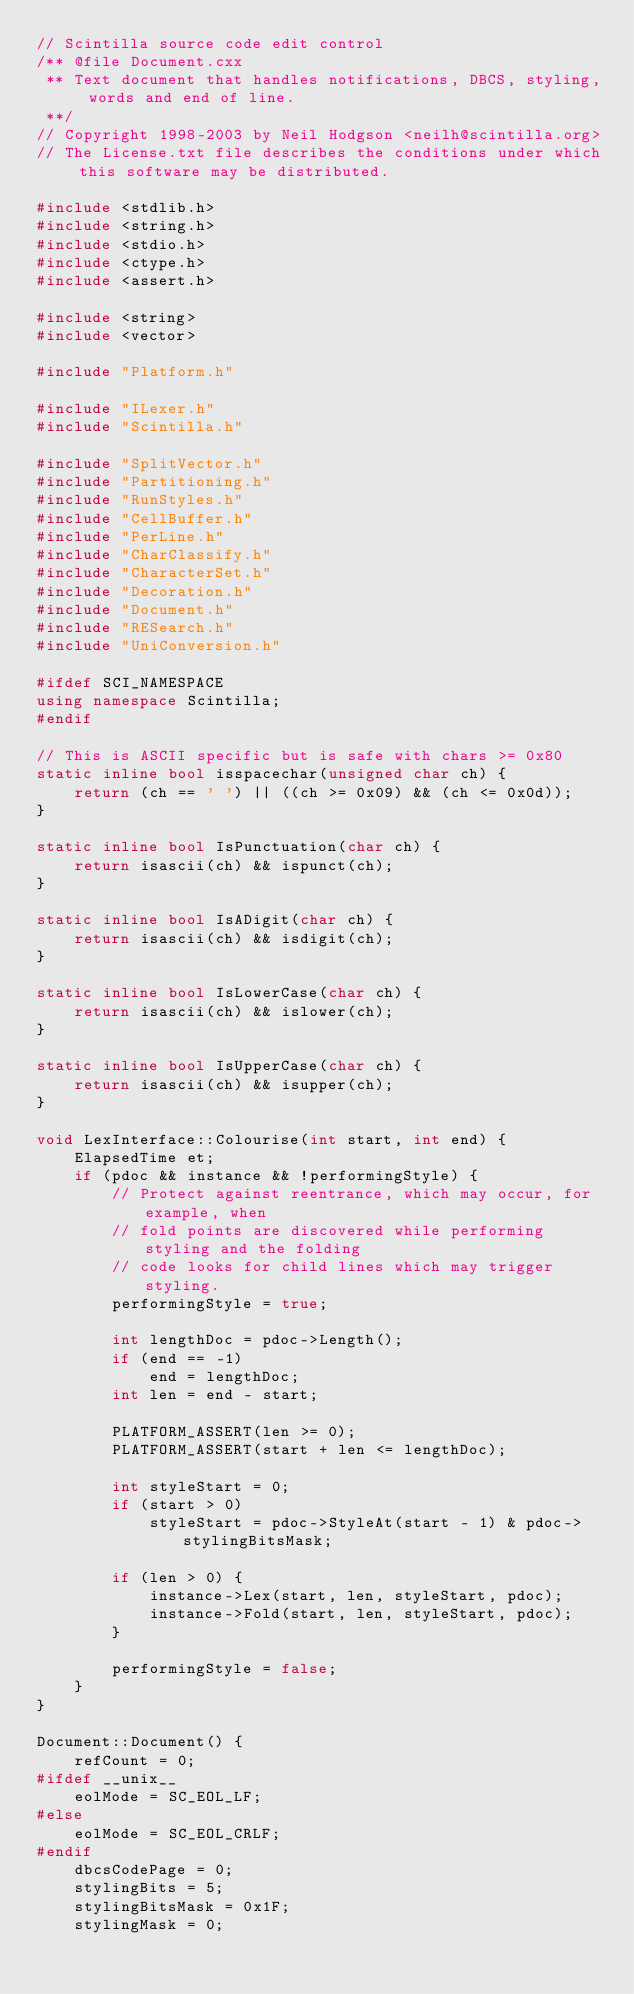Convert code to text. <code><loc_0><loc_0><loc_500><loc_500><_C++_>// Scintilla source code edit control
/** @file Document.cxx
 ** Text document that handles notifications, DBCS, styling, words and end of line.
 **/
// Copyright 1998-2003 by Neil Hodgson <neilh@scintilla.org>
// The License.txt file describes the conditions under which this software may be distributed.

#include <stdlib.h>
#include <string.h>
#include <stdio.h>
#include <ctype.h>
#include <assert.h>

#include <string>
#include <vector>

#include "Platform.h"

#include "ILexer.h"
#include "Scintilla.h"

#include "SplitVector.h"
#include "Partitioning.h"
#include "RunStyles.h"
#include "CellBuffer.h"
#include "PerLine.h"
#include "CharClassify.h"
#include "CharacterSet.h"
#include "Decoration.h"
#include "Document.h"
#include "RESearch.h"
#include "UniConversion.h"

#ifdef SCI_NAMESPACE
using namespace Scintilla;
#endif

// This is ASCII specific but is safe with chars >= 0x80
static inline bool isspacechar(unsigned char ch) {
	return (ch == ' ') || ((ch >= 0x09) && (ch <= 0x0d));
}

static inline bool IsPunctuation(char ch) {
	return isascii(ch) && ispunct(ch);
}

static inline bool IsADigit(char ch) {
	return isascii(ch) && isdigit(ch);
}

static inline bool IsLowerCase(char ch) {
	return isascii(ch) && islower(ch);
}

static inline bool IsUpperCase(char ch) {
	return isascii(ch) && isupper(ch);
}

void LexInterface::Colourise(int start, int end) {
	ElapsedTime et;
	if (pdoc && instance && !performingStyle) {
		// Protect against reentrance, which may occur, for example, when
		// fold points are discovered while performing styling and the folding
		// code looks for child lines which may trigger styling.
		performingStyle = true;

		int lengthDoc = pdoc->Length();
		if (end == -1)
			end = lengthDoc;
		int len = end - start;

		PLATFORM_ASSERT(len >= 0);
		PLATFORM_ASSERT(start + len <= lengthDoc);

		int styleStart = 0;
		if (start > 0)
			styleStart = pdoc->StyleAt(start - 1) & pdoc->stylingBitsMask;

		if (len > 0) {
			instance->Lex(start, len, styleStart, pdoc);
			instance->Fold(start, len, styleStart, pdoc);
		}

		performingStyle = false;
	}
}

Document::Document() {
	refCount = 0;
#ifdef __unix__
	eolMode = SC_EOL_LF;
#else
	eolMode = SC_EOL_CRLF;
#endif
	dbcsCodePage = 0;
	stylingBits = 5;
	stylingBitsMask = 0x1F;
	stylingMask = 0;</code> 